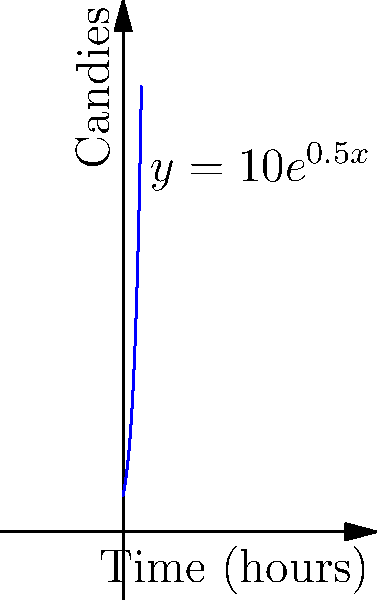In Candy Box, your candy production follows an exponential growth model represented by the function $y = 10e^{0.5x}$, where $y$ is the number of candies and $x$ is the time in hours. Based on the graph, approximately how many candies will you have after 4 hours? To solve this problem, we'll follow these steps:

1. Identify the function: $y = 10e^{0.5x}$
2. Substitute $x = 4$ (since we want to know the number of candies after 4 hours):
   $y = 10e^{0.5(4)}$
3. Simplify the exponent:
   $y = 10e^2$
4. Calculate $e^2$:
   $e^2 \approx 7.389$
5. Multiply by 10:
   $y \approx 10 * 7.389 = 73.89$

Looking at the graph, we can see that the curve passes through a point close to (4, 75), which confirms our calculation.

Therefore, after 4 hours, you will have approximately 74 candies.
Answer: 74 candies 